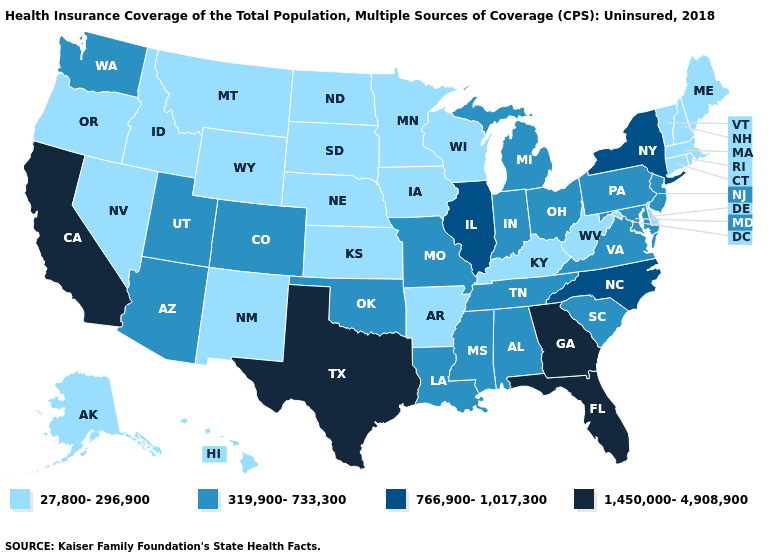How many symbols are there in the legend?
Be succinct. 4. What is the value of Oregon?
Write a very short answer. 27,800-296,900. Does Kentucky have a higher value than Colorado?
Give a very brief answer. No. Name the states that have a value in the range 319,900-733,300?
Quick response, please. Alabama, Arizona, Colorado, Indiana, Louisiana, Maryland, Michigan, Mississippi, Missouri, New Jersey, Ohio, Oklahoma, Pennsylvania, South Carolina, Tennessee, Utah, Virginia, Washington. What is the value of Florida?
Be succinct. 1,450,000-4,908,900. Name the states that have a value in the range 27,800-296,900?
Be succinct. Alaska, Arkansas, Connecticut, Delaware, Hawaii, Idaho, Iowa, Kansas, Kentucky, Maine, Massachusetts, Minnesota, Montana, Nebraska, Nevada, New Hampshire, New Mexico, North Dakota, Oregon, Rhode Island, South Dakota, Vermont, West Virginia, Wisconsin, Wyoming. Does Iowa have the lowest value in the MidWest?
Quick response, please. Yes. What is the value of Minnesota?
Be succinct. 27,800-296,900. Does Oklahoma have the highest value in the USA?
Answer briefly. No. Among the states that border Virginia , does Kentucky have the highest value?
Concise answer only. No. Does California have the highest value in the West?
Give a very brief answer. Yes. What is the lowest value in the USA?
Concise answer only. 27,800-296,900. Which states have the lowest value in the South?
Answer briefly. Arkansas, Delaware, Kentucky, West Virginia. Does the map have missing data?
Quick response, please. No. Does Kansas have the highest value in the MidWest?
Keep it brief. No. 